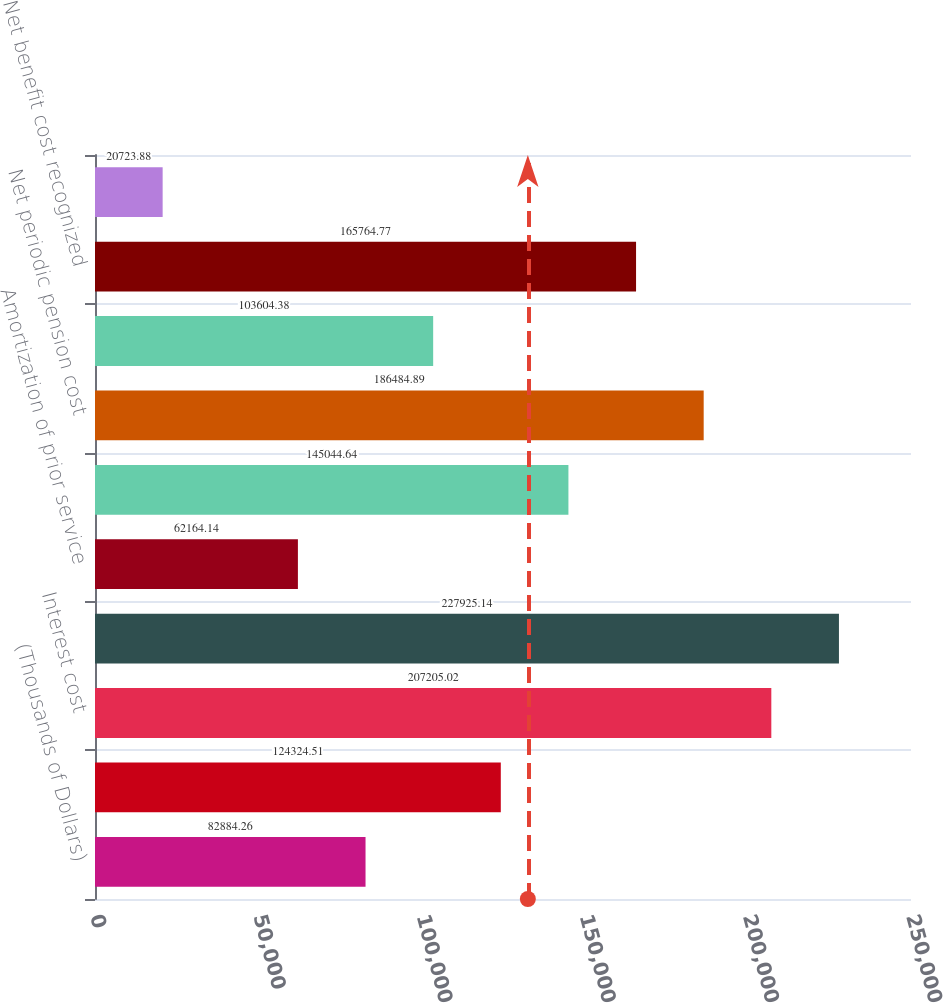Convert chart. <chart><loc_0><loc_0><loc_500><loc_500><bar_chart><fcel>(Thousands of Dollars)<fcel>Service cost<fcel>Interest cost<fcel>Expected return on plan assets<fcel>Amortization of prior service<fcel>Amortization of net loss<fcel>Net periodic pension cost<fcel>Costs not recognized due to<fcel>Net benefit cost recognized<fcel>Discount rate<nl><fcel>82884.3<fcel>124325<fcel>207205<fcel>227925<fcel>62164.1<fcel>145045<fcel>186485<fcel>103604<fcel>165765<fcel>20723.9<nl></chart> 